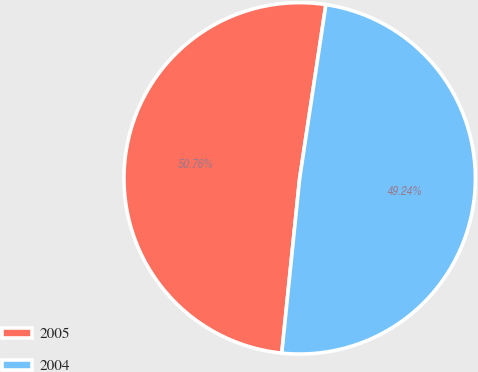<chart> <loc_0><loc_0><loc_500><loc_500><pie_chart><fcel>2005<fcel>2004<nl><fcel>50.76%<fcel>49.24%<nl></chart> 